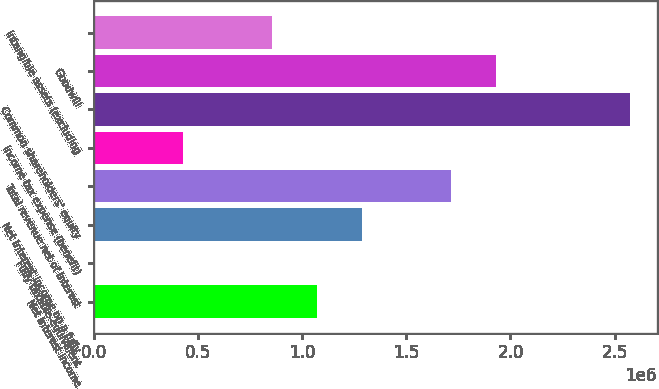<chart> <loc_0><loc_0><loc_500><loc_500><bar_chart><fcel>Net interest income<fcel>Fully taxable-equivalent<fcel>Net interest income on a fully<fcel>Total revenue net of interest<fcel>Income tax expense (benefit)<fcel>Common shareholders' equity<fcel>Goodwill<fcel>Intangible assets (excluding<nl><fcel>1.07227e+06<fcel>231<fcel>1.28668e+06<fcel>1.7155e+06<fcel>429048<fcel>2.57313e+06<fcel>1.92991e+06<fcel>857865<nl></chart> 